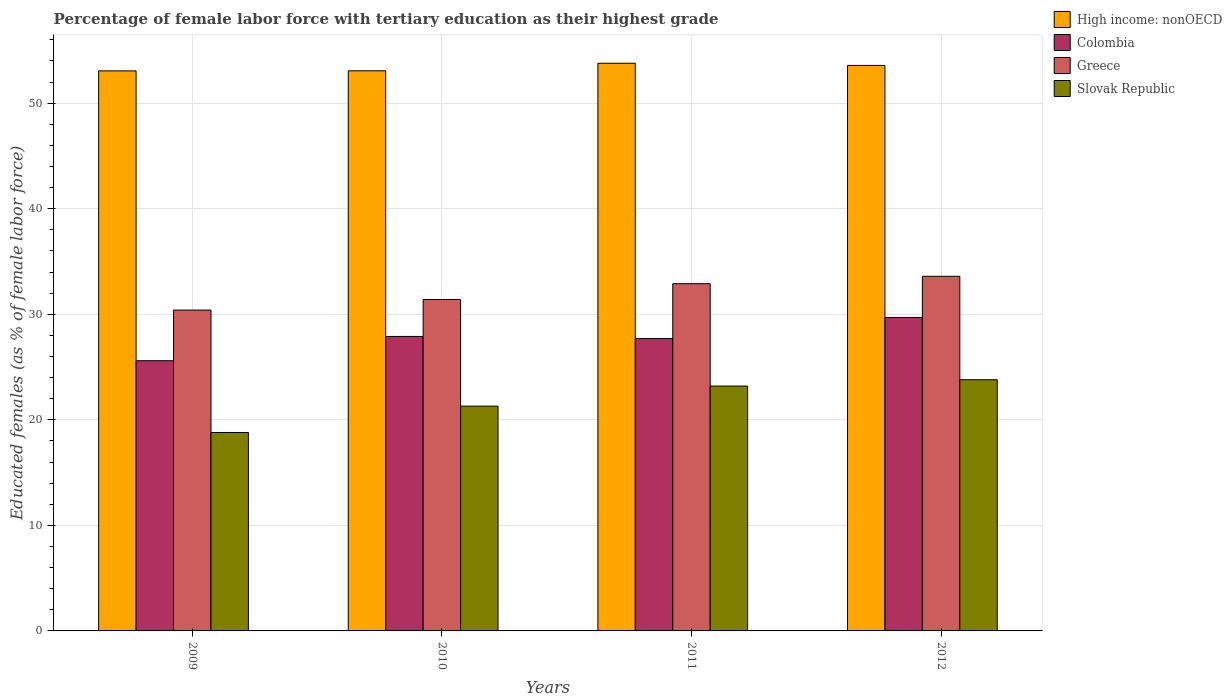Are the number of bars per tick equal to the number of legend labels?
Your answer should be very brief. Yes. Are the number of bars on each tick of the X-axis equal?
Give a very brief answer. Yes. How many bars are there on the 4th tick from the right?
Keep it short and to the point. 4. What is the label of the 2nd group of bars from the left?
Provide a short and direct response. 2010. What is the percentage of female labor force with tertiary education in High income: nonOECD in 2009?
Ensure brevity in your answer.  53.06. Across all years, what is the maximum percentage of female labor force with tertiary education in Slovak Republic?
Your answer should be very brief. 23.8. Across all years, what is the minimum percentage of female labor force with tertiary education in Colombia?
Ensure brevity in your answer.  25.6. In which year was the percentage of female labor force with tertiary education in High income: nonOECD minimum?
Offer a very short reply. 2009. What is the total percentage of female labor force with tertiary education in High income: nonOECD in the graph?
Ensure brevity in your answer.  213.49. What is the difference between the percentage of female labor force with tertiary education in Colombia in 2010 and that in 2012?
Your answer should be compact. -1.8. What is the difference between the percentage of female labor force with tertiary education in Colombia in 2009 and the percentage of female labor force with tertiary education in High income: nonOECD in 2012?
Ensure brevity in your answer.  -27.98. What is the average percentage of female labor force with tertiary education in Greece per year?
Offer a terse response. 32.07. What is the ratio of the percentage of female labor force with tertiary education in Colombia in 2009 to that in 2010?
Offer a terse response. 0.92. Is the percentage of female labor force with tertiary education in Colombia in 2009 less than that in 2010?
Give a very brief answer. Yes. What is the difference between the highest and the second highest percentage of female labor force with tertiary education in Greece?
Offer a very short reply. 0.7. What is the difference between the highest and the lowest percentage of female labor force with tertiary education in Colombia?
Provide a short and direct response. 4.1. In how many years, is the percentage of female labor force with tertiary education in Colombia greater than the average percentage of female labor force with tertiary education in Colombia taken over all years?
Provide a succinct answer. 2. Is the sum of the percentage of female labor force with tertiary education in Slovak Republic in 2009 and 2012 greater than the maximum percentage of female labor force with tertiary education in Greece across all years?
Your answer should be compact. Yes. Is it the case that in every year, the sum of the percentage of female labor force with tertiary education in Greece and percentage of female labor force with tertiary education in Colombia is greater than the sum of percentage of female labor force with tertiary education in Slovak Republic and percentage of female labor force with tertiary education in High income: nonOECD?
Your response must be concise. Yes. What does the 4th bar from the left in 2012 represents?
Provide a succinct answer. Slovak Republic. What does the 1st bar from the right in 2010 represents?
Provide a short and direct response. Slovak Republic. Is it the case that in every year, the sum of the percentage of female labor force with tertiary education in Colombia and percentage of female labor force with tertiary education in High income: nonOECD is greater than the percentage of female labor force with tertiary education in Slovak Republic?
Your response must be concise. Yes. How many years are there in the graph?
Offer a very short reply. 4. What is the difference between two consecutive major ticks on the Y-axis?
Keep it short and to the point. 10. Where does the legend appear in the graph?
Offer a very short reply. Top right. What is the title of the graph?
Keep it short and to the point. Percentage of female labor force with tertiary education as their highest grade. What is the label or title of the Y-axis?
Your answer should be compact. Educated females (as % of female labor force). What is the Educated females (as % of female labor force) of High income: nonOECD in 2009?
Your response must be concise. 53.06. What is the Educated females (as % of female labor force) in Colombia in 2009?
Provide a short and direct response. 25.6. What is the Educated females (as % of female labor force) of Greece in 2009?
Offer a terse response. 30.4. What is the Educated females (as % of female labor force) of Slovak Republic in 2009?
Provide a succinct answer. 18.8. What is the Educated females (as % of female labor force) of High income: nonOECD in 2010?
Provide a short and direct response. 53.07. What is the Educated females (as % of female labor force) of Colombia in 2010?
Give a very brief answer. 27.9. What is the Educated females (as % of female labor force) in Greece in 2010?
Your answer should be compact. 31.4. What is the Educated females (as % of female labor force) of Slovak Republic in 2010?
Ensure brevity in your answer.  21.3. What is the Educated females (as % of female labor force) of High income: nonOECD in 2011?
Offer a terse response. 53.78. What is the Educated females (as % of female labor force) of Colombia in 2011?
Ensure brevity in your answer.  27.7. What is the Educated females (as % of female labor force) of Greece in 2011?
Provide a succinct answer. 32.9. What is the Educated females (as % of female labor force) of Slovak Republic in 2011?
Your response must be concise. 23.2. What is the Educated females (as % of female labor force) of High income: nonOECD in 2012?
Provide a succinct answer. 53.58. What is the Educated females (as % of female labor force) in Colombia in 2012?
Ensure brevity in your answer.  29.7. What is the Educated females (as % of female labor force) of Greece in 2012?
Your answer should be very brief. 33.6. What is the Educated females (as % of female labor force) of Slovak Republic in 2012?
Ensure brevity in your answer.  23.8. Across all years, what is the maximum Educated females (as % of female labor force) of High income: nonOECD?
Provide a succinct answer. 53.78. Across all years, what is the maximum Educated females (as % of female labor force) in Colombia?
Ensure brevity in your answer.  29.7. Across all years, what is the maximum Educated females (as % of female labor force) of Greece?
Make the answer very short. 33.6. Across all years, what is the maximum Educated females (as % of female labor force) of Slovak Republic?
Keep it short and to the point. 23.8. Across all years, what is the minimum Educated females (as % of female labor force) of High income: nonOECD?
Your answer should be compact. 53.06. Across all years, what is the minimum Educated females (as % of female labor force) of Colombia?
Provide a short and direct response. 25.6. Across all years, what is the minimum Educated females (as % of female labor force) of Greece?
Ensure brevity in your answer.  30.4. Across all years, what is the minimum Educated females (as % of female labor force) in Slovak Republic?
Your answer should be very brief. 18.8. What is the total Educated females (as % of female labor force) in High income: nonOECD in the graph?
Provide a succinct answer. 213.49. What is the total Educated females (as % of female labor force) in Colombia in the graph?
Your answer should be compact. 110.9. What is the total Educated females (as % of female labor force) in Greece in the graph?
Give a very brief answer. 128.3. What is the total Educated females (as % of female labor force) of Slovak Republic in the graph?
Make the answer very short. 87.1. What is the difference between the Educated females (as % of female labor force) of High income: nonOECD in 2009 and that in 2010?
Offer a terse response. -0.01. What is the difference between the Educated females (as % of female labor force) in Colombia in 2009 and that in 2010?
Make the answer very short. -2.3. What is the difference between the Educated females (as % of female labor force) of High income: nonOECD in 2009 and that in 2011?
Provide a succinct answer. -0.72. What is the difference between the Educated females (as % of female labor force) in Slovak Republic in 2009 and that in 2011?
Make the answer very short. -4.4. What is the difference between the Educated females (as % of female labor force) in High income: nonOECD in 2009 and that in 2012?
Your answer should be very brief. -0.52. What is the difference between the Educated females (as % of female labor force) of Colombia in 2009 and that in 2012?
Your answer should be compact. -4.1. What is the difference between the Educated females (as % of female labor force) of High income: nonOECD in 2010 and that in 2011?
Give a very brief answer. -0.71. What is the difference between the Educated females (as % of female labor force) of Slovak Republic in 2010 and that in 2011?
Your response must be concise. -1.9. What is the difference between the Educated females (as % of female labor force) of High income: nonOECD in 2010 and that in 2012?
Offer a very short reply. -0.51. What is the difference between the Educated females (as % of female labor force) of High income: nonOECD in 2011 and that in 2012?
Give a very brief answer. 0.2. What is the difference between the Educated females (as % of female labor force) in Greece in 2011 and that in 2012?
Give a very brief answer. -0.7. What is the difference between the Educated females (as % of female labor force) in Slovak Republic in 2011 and that in 2012?
Your answer should be very brief. -0.6. What is the difference between the Educated females (as % of female labor force) of High income: nonOECD in 2009 and the Educated females (as % of female labor force) of Colombia in 2010?
Offer a terse response. 25.16. What is the difference between the Educated females (as % of female labor force) in High income: nonOECD in 2009 and the Educated females (as % of female labor force) in Greece in 2010?
Offer a very short reply. 21.66. What is the difference between the Educated females (as % of female labor force) in High income: nonOECD in 2009 and the Educated females (as % of female labor force) in Slovak Republic in 2010?
Your answer should be very brief. 31.76. What is the difference between the Educated females (as % of female labor force) of Colombia in 2009 and the Educated females (as % of female labor force) of Greece in 2010?
Ensure brevity in your answer.  -5.8. What is the difference between the Educated females (as % of female labor force) of Colombia in 2009 and the Educated females (as % of female labor force) of Slovak Republic in 2010?
Provide a short and direct response. 4.3. What is the difference between the Educated females (as % of female labor force) of High income: nonOECD in 2009 and the Educated females (as % of female labor force) of Colombia in 2011?
Ensure brevity in your answer.  25.36. What is the difference between the Educated females (as % of female labor force) in High income: nonOECD in 2009 and the Educated females (as % of female labor force) in Greece in 2011?
Offer a very short reply. 20.16. What is the difference between the Educated females (as % of female labor force) in High income: nonOECD in 2009 and the Educated females (as % of female labor force) in Slovak Republic in 2011?
Give a very brief answer. 29.86. What is the difference between the Educated females (as % of female labor force) of Colombia in 2009 and the Educated females (as % of female labor force) of Slovak Republic in 2011?
Keep it short and to the point. 2.4. What is the difference between the Educated females (as % of female labor force) in High income: nonOECD in 2009 and the Educated females (as % of female labor force) in Colombia in 2012?
Ensure brevity in your answer.  23.36. What is the difference between the Educated females (as % of female labor force) in High income: nonOECD in 2009 and the Educated females (as % of female labor force) in Greece in 2012?
Offer a terse response. 19.46. What is the difference between the Educated females (as % of female labor force) in High income: nonOECD in 2009 and the Educated females (as % of female labor force) in Slovak Republic in 2012?
Offer a terse response. 29.26. What is the difference between the Educated females (as % of female labor force) in High income: nonOECD in 2010 and the Educated females (as % of female labor force) in Colombia in 2011?
Your answer should be very brief. 25.37. What is the difference between the Educated females (as % of female labor force) of High income: nonOECD in 2010 and the Educated females (as % of female labor force) of Greece in 2011?
Give a very brief answer. 20.17. What is the difference between the Educated females (as % of female labor force) of High income: nonOECD in 2010 and the Educated females (as % of female labor force) of Slovak Republic in 2011?
Keep it short and to the point. 29.87. What is the difference between the Educated females (as % of female labor force) in Colombia in 2010 and the Educated females (as % of female labor force) in Slovak Republic in 2011?
Provide a short and direct response. 4.7. What is the difference between the Educated females (as % of female labor force) in Greece in 2010 and the Educated females (as % of female labor force) in Slovak Republic in 2011?
Give a very brief answer. 8.2. What is the difference between the Educated females (as % of female labor force) of High income: nonOECD in 2010 and the Educated females (as % of female labor force) of Colombia in 2012?
Make the answer very short. 23.37. What is the difference between the Educated females (as % of female labor force) in High income: nonOECD in 2010 and the Educated females (as % of female labor force) in Greece in 2012?
Keep it short and to the point. 19.47. What is the difference between the Educated females (as % of female labor force) in High income: nonOECD in 2010 and the Educated females (as % of female labor force) in Slovak Republic in 2012?
Offer a very short reply. 29.27. What is the difference between the Educated females (as % of female labor force) in Colombia in 2010 and the Educated females (as % of female labor force) in Slovak Republic in 2012?
Make the answer very short. 4.1. What is the difference between the Educated females (as % of female labor force) in Greece in 2010 and the Educated females (as % of female labor force) in Slovak Republic in 2012?
Give a very brief answer. 7.6. What is the difference between the Educated females (as % of female labor force) of High income: nonOECD in 2011 and the Educated females (as % of female labor force) of Colombia in 2012?
Your answer should be compact. 24.08. What is the difference between the Educated females (as % of female labor force) of High income: nonOECD in 2011 and the Educated females (as % of female labor force) of Greece in 2012?
Provide a succinct answer. 20.18. What is the difference between the Educated females (as % of female labor force) of High income: nonOECD in 2011 and the Educated females (as % of female labor force) of Slovak Republic in 2012?
Keep it short and to the point. 29.98. What is the difference between the Educated females (as % of female labor force) in Colombia in 2011 and the Educated females (as % of female labor force) in Greece in 2012?
Your response must be concise. -5.9. What is the difference between the Educated females (as % of female labor force) of Colombia in 2011 and the Educated females (as % of female labor force) of Slovak Republic in 2012?
Your answer should be very brief. 3.9. What is the difference between the Educated females (as % of female labor force) in Greece in 2011 and the Educated females (as % of female labor force) in Slovak Republic in 2012?
Your answer should be compact. 9.1. What is the average Educated females (as % of female labor force) in High income: nonOECD per year?
Offer a very short reply. 53.37. What is the average Educated females (as % of female labor force) of Colombia per year?
Offer a very short reply. 27.73. What is the average Educated females (as % of female labor force) in Greece per year?
Your answer should be very brief. 32.08. What is the average Educated females (as % of female labor force) in Slovak Republic per year?
Give a very brief answer. 21.77. In the year 2009, what is the difference between the Educated females (as % of female labor force) of High income: nonOECD and Educated females (as % of female labor force) of Colombia?
Make the answer very short. 27.46. In the year 2009, what is the difference between the Educated females (as % of female labor force) in High income: nonOECD and Educated females (as % of female labor force) in Greece?
Your response must be concise. 22.66. In the year 2009, what is the difference between the Educated females (as % of female labor force) of High income: nonOECD and Educated females (as % of female labor force) of Slovak Republic?
Your answer should be very brief. 34.26. In the year 2009, what is the difference between the Educated females (as % of female labor force) in Colombia and Educated females (as % of female labor force) in Slovak Republic?
Your response must be concise. 6.8. In the year 2009, what is the difference between the Educated females (as % of female labor force) in Greece and Educated females (as % of female labor force) in Slovak Republic?
Make the answer very short. 11.6. In the year 2010, what is the difference between the Educated females (as % of female labor force) in High income: nonOECD and Educated females (as % of female labor force) in Colombia?
Offer a terse response. 25.17. In the year 2010, what is the difference between the Educated females (as % of female labor force) in High income: nonOECD and Educated females (as % of female labor force) in Greece?
Ensure brevity in your answer.  21.67. In the year 2010, what is the difference between the Educated females (as % of female labor force) of High income: nonOECD and Educated females (as % of female labor force) of Slovak Republic?
Provide a short and direct response. 31.77. In the year 2010, what is the difference between the Educated females (as % of female labor force) of Colombia and Educated females (as % of female labor force) of Greece?
Your answer should be compact. -3.5. In the year 2011, what is the difference between the Educated females (as % of female labor force) in High income: nonOECD and Educated females (as % of female labor force) in Colombia?
Your response must be concise. 26.08. In the year 2011, what is the difference between the Educated females (as % of female labor force) of High income: nonOECD and Educated females (as % of female labor force) of Greece?
Provide a short and direct response. 20.88. In the year 2011, what is the difference between the Educated females (as % of female labor force) of High income: nonOECD and Educated females (as % of female labor force) of Slovak Republic?
Your answer should be very brief. 30.58. In the year 2012, what is the difference between the Educated females (as % of female labor force) in High income: nonOECD and Educated females (as % of female labor force) in Colombia?
Your answer should be compact. 23.88. In the year 2012, what is the difference between the Educated females (as % of female labor force) of High income: nonOECD and Educated females (as % of female labor force) of Greece?
Keep it short and to the point. 19.98. In the year 2012, what is the difference between the Educated females (as % of female labor force) of High income: nonOECD and Educated females (as % of female labor force) of Slovak Republic?
Offer a very short reply. 29.78. In the year 2012, what is the difference between the Educated females (as % of female labor force) of Colombia and Educated females (as % of female labor force) of Slovak Republic?
Provide a short and direct response. 5.9. In the year 2012, what is the difference between the Educated females (as % of female labor force) of Greece and Educated females (as % of female labor force) of Slovak Republic?
Give a very brief answer. 9.8. What is the ratio of the Educated females (as % of female labor force) of High income: nonOECD in 2009 to that in 2010?
Keep it short and to the point. 1. What is the ratio of the Educated females (as % of female labor force) of Colombia in 2009 to that in 2010?
Provide a succinct answer. 0.92. What is the ratio of the Educated females (as % of female labor force) of Greece in 2009 to that in 2010?
Offer a terse response. 0.97. What is the ratio of the Educated females (as % of female labor force) in Slovak Republic in 2009 to that in 2010?
Provide a succinct answer. 0.88. What is the ratio of the Educated females (as % of female labor force) of High income: nonOECD in 2009 to that in 2011?
Provide a succinct answer. 0.99. What is the ratio of the Educated females (as % of female labor force) of Colombia in 2009 to that in 2011?
Offer a very short reply. 0.92. What is the ratio of the Educated females (as % of female labor force) of Greece in 2009 to that in 2011?
Provide a short and direct response. 0.92. What is the ratio of the Educated females (as % of female labor force) in Slovak Republic in 2009 to that in 2011?
Your response must be concise. 0.81. What is the ratio of the Educated females (as % of female labor force) of High income: nonOECD in 2009 to that in 2012?
Offer a terse response. 0.99. What is the ratio of the Educated females (as % of female labor force) in Colombia in 2009 to that in 2012?
Your answer should be very brief. 0.86. What is the ratio of the Educated females (as % of female labor force) of Greece in 2009 to that in 2012?
Keep it short and to the point. 0.9. What is the ratio of the Educated females (as % of female labor force) of Slovak Republic in 2009 to that in 2012?
Offer a terse response. 0.79. What is the ratio of the Educated females (as % of female labor force) of High income: nonOECD in 2010 to that in 2011?
Your answer should be very brief. 0.99. What is the ratio of the Educated females (as % of female labor force) in Colombia in 2010 to that in 2011?
Give a very brief answer. 1.01. What is the ratio of the Educated females (as % of female labor force) of Greece in 2010 to that in 2011?
Offer a very short reply. 0.95. What is the ratio of the Educated females (as % of female labor force) of Slovak Republic in 2010 to that in 2011?
Provide a short and direct response. 0.92. What is the ratio of the Educated females (as % of female labor force) in High income: nonOECD in 2010 to that in 2012?
Give a very brief answer. 0.99. What is the ratio of the Educated females (as % of female labor force) in Colombia in 2010 to that in 2012?
Give a very brief answer. 0.94. What is the ratio of the Educated females (as % of female labor force) in Greece in 2010 to that in 2012?
Keep it short and to the point. 0.93. What is the ratio of the Educated females (as % of female labor force) of Slovak Republic in 2010 to that in 2012?
Provide a succinct answer. 0.9. What is the ratio of the Educated females (as % of female labor force) in Colombia in 2011 to that in 2012?
Make the answer very short. 0.93. What is the ratio of the Educated females (as % of female labor force) in Greece in 2011 to that in 2012?
Offer a very short reply. 0.98. What is the ratio of the Educated females (as % of female labor force) of Slovak Republic in 2011 to that in 2012?
Your response must be concise. 0.97. What is the difference between the highest and the second highest Educated females (as % of female labor force) of High income: nonOECD?
Your answer should be very brief. 0.2. What is the difference between the highest and the second highest Educated females (as % of female labor force) of Greece?
Provide a succinct answer. 0.7. What is the difference between the highest and the lowest Educated females (as % of female labor force) in High income: nonOECD?
Offer a very short reply. 0.72. What is the difference between the highest and the lowest Educated females (as % of female labor force) of Greece?
Provide a short and direct response. 3.2. What is the difference between the highest and the lowest Educated females (as % of female labor force) in Slovak Republic?
Make the answer very short. 5. 